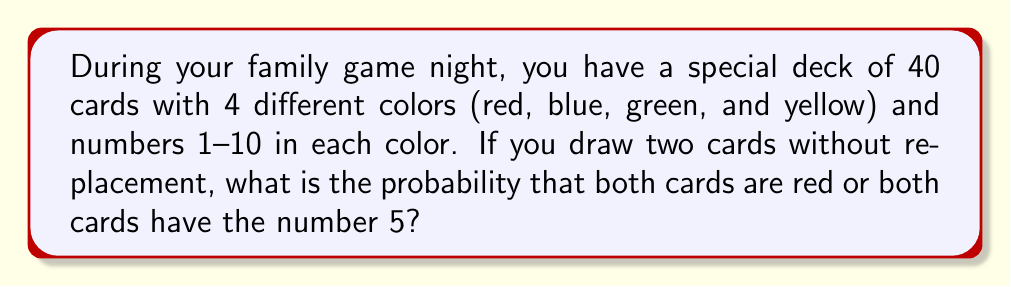Help me with this question. Let's break this down step-by-step:

1) First, let's calculate the total number of ways to draw 2 cards from 40 cards:
   $${40 \choose 2} = \frac{40!}{2!(40-2)!} = \frac{40 \cdot 39}{2} = 780$$

2) Now, let's calculate the number of ways to draw 2 red cards:
   There are 10 red cards, so: $${10 \choose 2} = \frac{10 \cdot 9}{2} = 45$$

3) Next, let's calculate the number of ways to draw 2 cards with the number 5:
   There are 4 cards with the number 5 (one in each color), so: $${4 \choose 2} = \frac{4 \cdot 3}{2} = 6$$

4) However, we've double-counted the case where both cards are red 5s. We need to subtract this:
   There's only 1 way to draw two red 5s: ${1 \choose 2} = 1$

5) So, the total number of favorable outcomes is:
   $45 + 6 - 1 = 50$

6) The probability is therefore:
   $$P(\text{both red or both 5}) = \frac{50}{780} = \frac{25}{390} \approx 0.0641$$
Answer: $\frac{25}{390}$ 